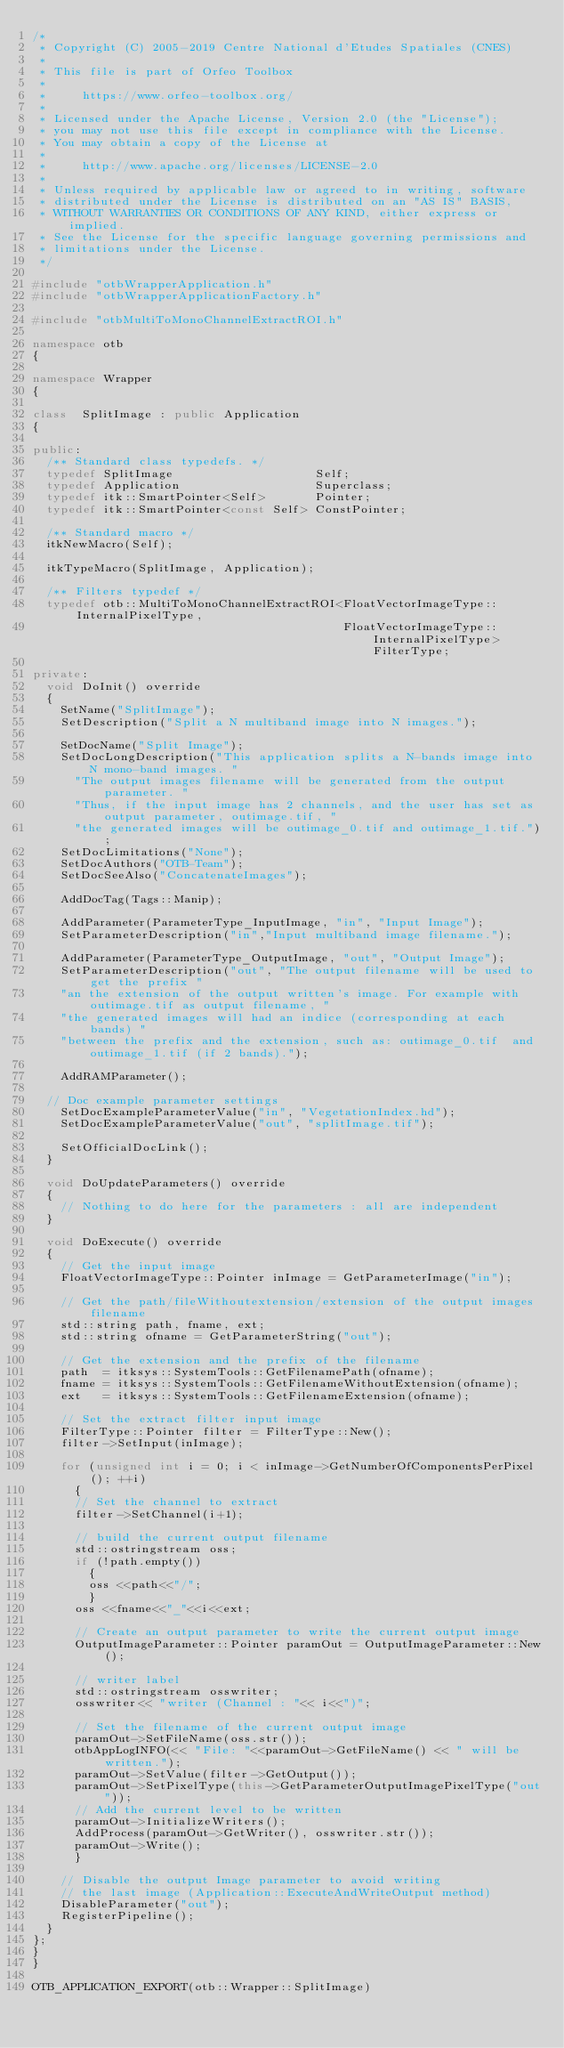<code> <loc_0><loc_0><loc_500><loc_500><_C++_>/*
 * Copyright (C) 2005-2019 Centre National d'Etudes Spatiales (CNES)
 *
 * This file is part of Orfeo Toolbox
 *
 *     https://www.orfeo-toolbox.org/
 *
 * Licensed under the Apache License, Version 2.0 (the "License");
 * you may not use this file except in compliance with the License.
 * You may obtain a copy of the License at
 *
 *     http://www.apache.org/licenses/LICENSE-2.0
 *
 * Unless required by applicable law or agreed to in writing, software
 * distributed under the License is distributed on an "AS IS" BASIS,
 * WITHOUT WARRANTIES OR CONDITIONS OF ANY KIND, either express or implied.
 * See the License for the specific language governing permissions and
 * limitations under the License.
 */

#include "otbWrapperApplication.h"
#include "otbWrapperApplicationFactory.h"

#include "otbMultiToMonoChannelExtractROI.h"

namespace otb
{

namespace Wrapper
{

class  SplitImage : public Application
{

public:
  /** Standard class typedefs. */
  typedef SplitImage                    Self;
  typedef Application                   Superclass;
  typedef itk::SmartPointer<Self>       Pointer;
  typedef itk::SmartPointer<const Self> ConstPointer;

  /** Standard macro */
  itkNewMacro(Self);

  itkTypeMacro(SplitImage, Application);

  /** Filters typedef */
  typedef otb::MultiToMonoChannelExtractROI<FloatVectorImageType::InternalPixelType,
                                            FloatVectorImageType::InternalPixelType> FilterType;

private:
  void DoInit() override
  {
    SetName("SplitImage");
    SetDescription("Split a N multiband image into N images.");

    SetDocName("Split Image");
    SetDocLongDescription("This application splits a N-bands image into N mono-band images. "
      "The output images filename will be generated from the output parameter. "
      "Thus, if the input image has 2 channels, and the user has set as output parameter, outimage.tif, "
      "the generated images will be outimage_0.tif and outimage_1.tif.");
    SetDocLimitations("None");
    SetDocAuthors("OTB-Team");
    SetDocSeeAlso("ConcatenateImages");

    AddDocTag(Tags::Manip);

    AddParameter(ParameterType_InputImage, "in", "Input Image");
    SetParameterDescription("in","Input multiband image filename.");

    AddParameter(ParameterType_OutputImage, "out", "Output Image");
    SetParameterDescription("out", "The output filename will be used to get the prefix "
    "an the extension of the output written's image. For example with outimage.tif as output filename, "
    "the generated images will had an indice (corresponding at each bands) "
    "between the prefix and the extension, such as: outimage_0.tif  and outimage_1.tif (if 2 bands).");

    AddRAMParameter();

  // Doc example parameter settings
    SetDocExampleParameterValue("in", "VegetationIndex.hd");
    SetDocExampleParameterValue("out", "splitImage.tif");

    SetOfficialDocLink();
  }

  void DoUpdateParameters() override
  {
    // Nothing to do here for the parameters : all are independent
  }

  void DoExecute() override
  {
    // Get the input image
    FloatVectorImageType::Pointer inImage = GetParameterImage("in");

    // Get the path/fileWithoutextension/extension of the output images filename
    std::string path, fname, ext;
    std::string ofname = GetParameterString("out");

    // Get the extension and the prefix of the filename
    path  = itksys::SystemTools::GetFilenamePath(ofname);
    fname = itksys::SystemTools::GetFilenameWithoutExtension(ofname);
    ext   = itksys::SystemTools::GetFilenameExtension(ofname);

    // Set the extract filter input image
    FilterType::Pointer filter = FilterType::New();
    filter->SetInput(inImage);

    for (unsigned int i = 0; i < inImage->GetNumberOfComponentsPerPixel(); ++i)
      {
      // Set the channel to extract
      filter->SetChannel(i+1);

      // build the current output filename
      std::ostringstream oss;
      if (!path.empty())
        {
        oss <<path<<"/";
        }
      oss <<fname<<"_"<<i<<ext;

      // Create an output parameter to write the current output image
      OutputImageParameter::Pointer paramOut = OutputImageParameter::New();

      // writer label
      std::ostringstream osswriter;
      osswriter<< "writer (Channel : "<< i<<")";

      // Set the filename of the current output image
      paramOut->SetFileName(oss.str());
      otbAppLogINFO(<< "File: "<<paramOut->GetFileName() << " will be written.");
      paramOut->SetValue(filter->GetOutput());
      paramOut->SetPixelType(this->GetParameterOutputImagePixelType("out"));
      // Add the current level to be written
      paramOut->InitializeWriters();
      AddProcess(paramOut->GetWriter(), osswriter.str());
      paramOut->Write();
      }

    // Disable the output Image parameter to avoid writing
    // the last image (Application::ExecuteAndWriteOutput method)
    DisableParameter("out");
    RegisterPipeline();
  }
};
}
}

OTB_APPLICATION_EXPORT(otb::Wrapper::SplitImage)

</code> 